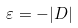<formula> <loc_0><loc_0><loc_500><loc_500>\varepsilon = - | D |</formula> 